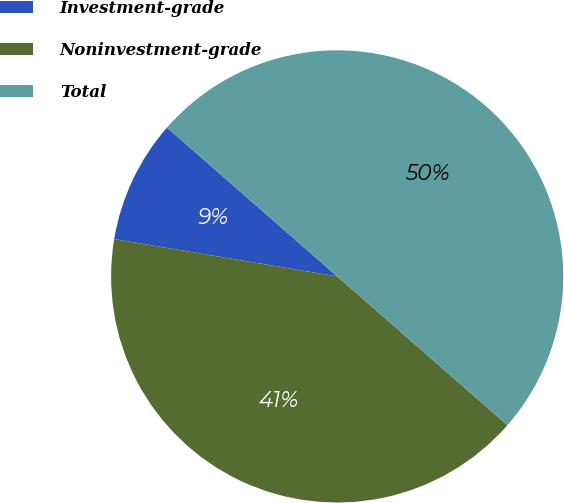Convert chart to OTSL. <chart><loc_0><loc_0><loc_500><loc_500><pie_chart><fcel>Investment-grade<fcel>Noninvestment-grade<fcel>Total<nl><fcel>8.79%<fcel>41.21%<fcel>50.0%<nl></chart> 